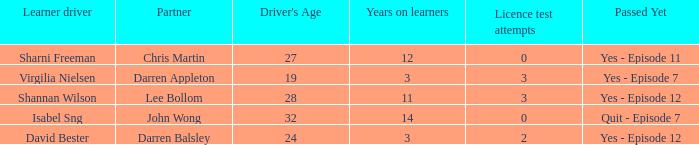For drivers older than 24 with fewer than one attempt at the license test, what is the average duration of their learning period? None. 